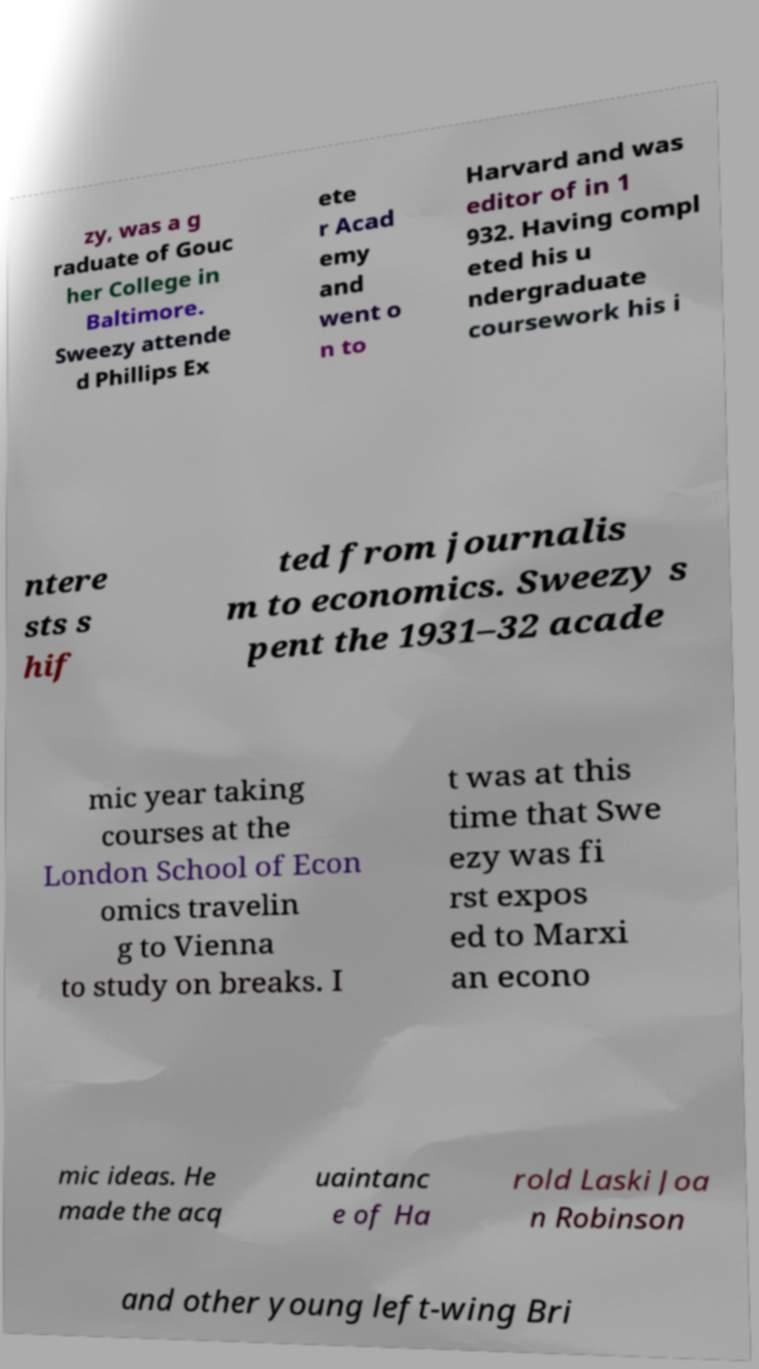Please identify and transcribe the text found in this image. zy, was a g raduate of Gouc her College in Baltimore. Sweezy attende d Phillips Ex ete r Acad emy and went o n to Harvard and was editor of in 1 932. Having compl eted his u ndergraduate coursework his i ntere sts s hif ted from journalis m to economics. Sweezy s pent the 1931–32 acade mic year taking courses at the London School of Econ omics travelin g to Vienna to study on breaks. I t was at this time that Swe ezy was fi rst expos ed to Marxi an econo mic ideas. He made the acq uaintanc e of Ha rold Laski Joa n Robinson and other young left-wing Bri 